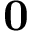<formula> <loc_0><loc_0><loc_500><loc_500>0</formula> 